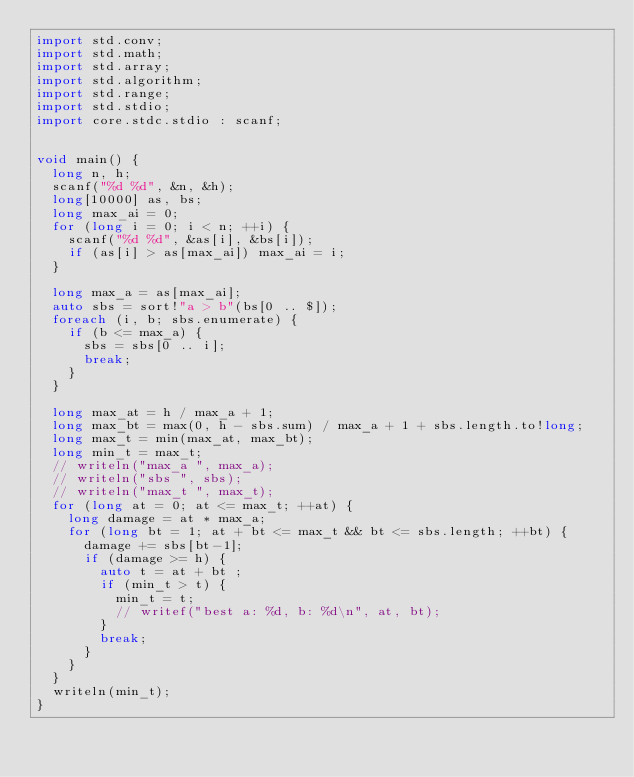<code> <loc_0><loc_0><loc_500><loc_500><_D_>import std.conv;
import std.math;
import std.array;
import std.algorithm;
import std.range;
import std.stdio;
import core.stdc.stdio : scanf;


void main() {
  long n, h;
  scanf("%d %d", &n, &h);
  long[10000] as, bs;
  long max_ai = 0;
  for (long i = 0; i < n; ++i) {
    scanf("%d %d", &as[i], &bs[i]);
    if (as[i] > as[max_ai]) max_ai = i;
  }

  long max_a = as[max_ai];
  auto sbs = sort!"a > b"(bs[0 .. $]);
  foreach (i, b; sbs.enumerate) {
    if (b <= max_a) {
      sbs = sbs[0 .. i];
      break;
    }
  }

  long max_at = h / max_a + 1;
  long max_bt = max(0, h - sbs.sum) / max_a + 1 + sbs.length.to!long;
  long max_t = min(max_at, max_bt);
  long min_t = max_t;
  // writeln("max_a ", max_a);
  // writeln("sbs ", sbs);
  // writeln("max_t ", max_t);
  for (long at = 0; at <= max_t; ++at) {
    long damage = at * max_a;
    for (long bt = 1; at + bt <= max_t && bt <= sbs.length; ++bt) {
      damage += sbs[bt-1];
      if (damage >= h) {
        auto t = at + bt ;
        if (min_t > t) {
          min_t = t;
          // writef("best a: %d, b: %d\n", at, bt);
        }
        break;
      }
    }
  }
  writeln(min_t);
}
</code> 